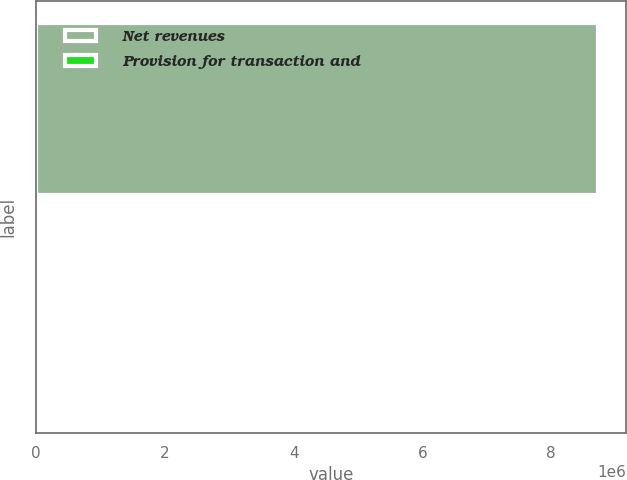Convert chart to OTSL. <chart><loc_0><loc_0><loc_500><loc_500><bar_chart><fcel>Net revenues<fcel>Provision for transaction and<nl><fcel>8.72736e+06<fcel>4.4<nl></chart> 